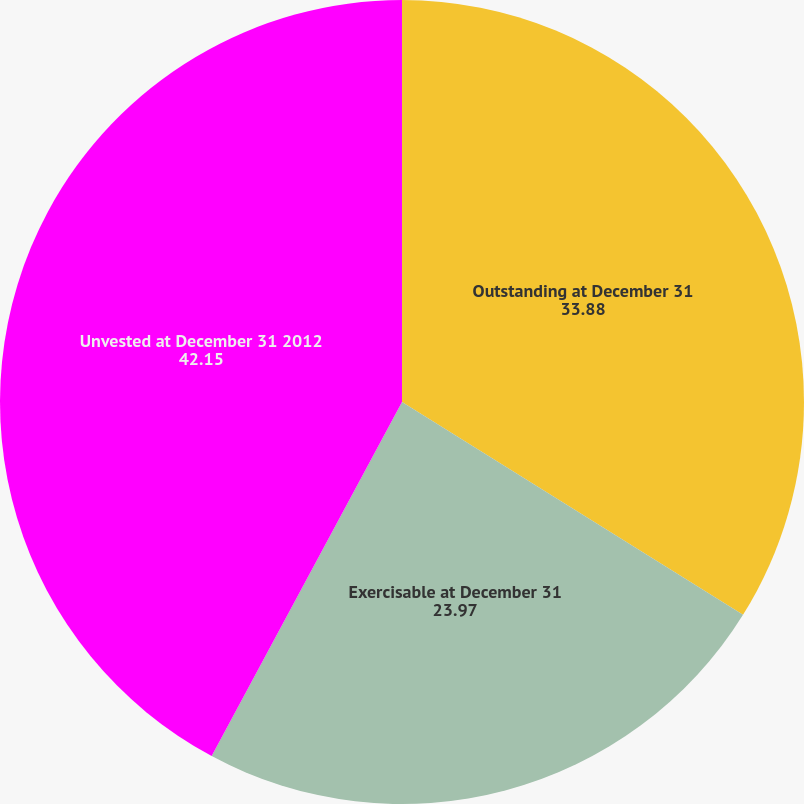Convert chart. <chart><loc_0><loc_0><loc_500><loc_500><pie_chart><fcel>Outstanding at December 31<fcel>Exercisable at December 31<fcel>Unvested at December 31 2012<nl><fcel>33.88%<fcel>23.97%<fcel>42.15%<nl></chart> 